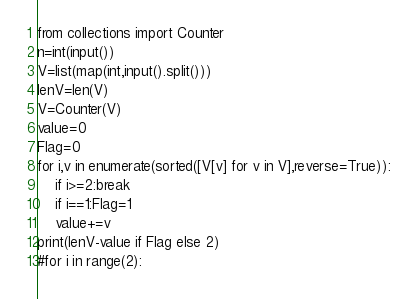<code> <loc_0><loc_0><loc_500><loc_500><_Python_>from collections import Counter
n=int(input())
V=list(map(int,input().split()))
lenV=len(V)
V=Counter(V)
value=0
Flag=0
for i,v in enumerate(sorted([V[v] for v in V],reverse=True)):
    if i>=2:break
    if i==1:Flag=1
    value+=v
print(lenV-value if Flag else 2)
#for i in range(2):
</code> 